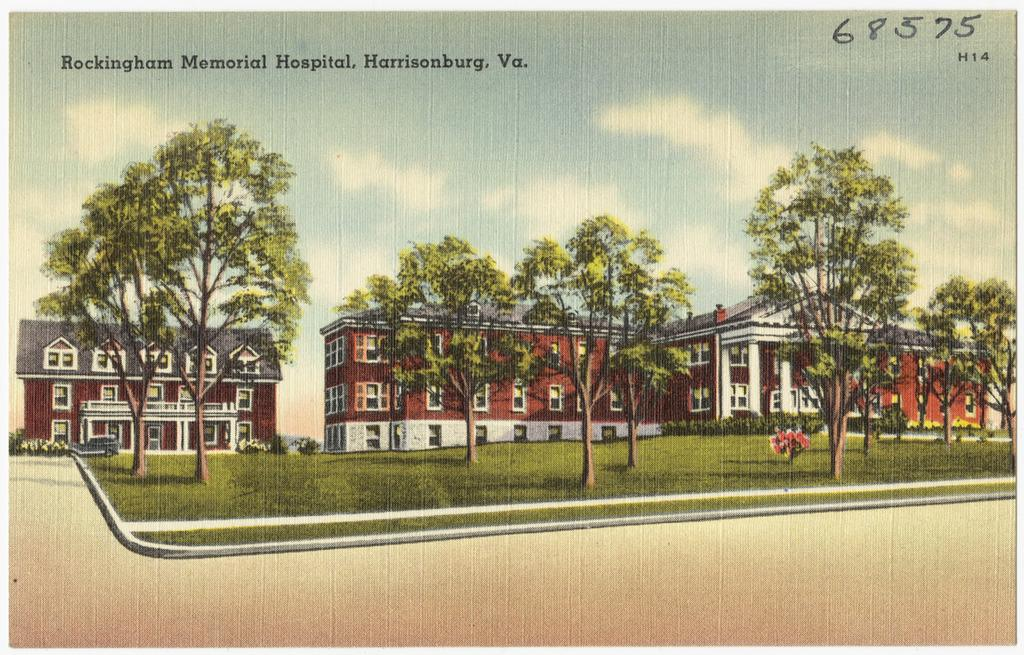What type of artwork is depicted in the image? The image is a painting. What natural elements can be seen in the painting? There are trees and grass on the ground in the painting. What man-made structures are present in the painting? There are buildings in the painting. What is the condition of the sky in the painting? The sky is cloudy in the painting. Is there any text present in the image? Yes, there is text written on the image. What type of hook is hanging from the tree in the painting? There is no hook present in the painting; it features trees, buildings, grass, and text. What ornament is hanging from the buildings in the painting? There is no ornament hanging from the buildings in the painting; it only features buildings, trees, grass, and text. 